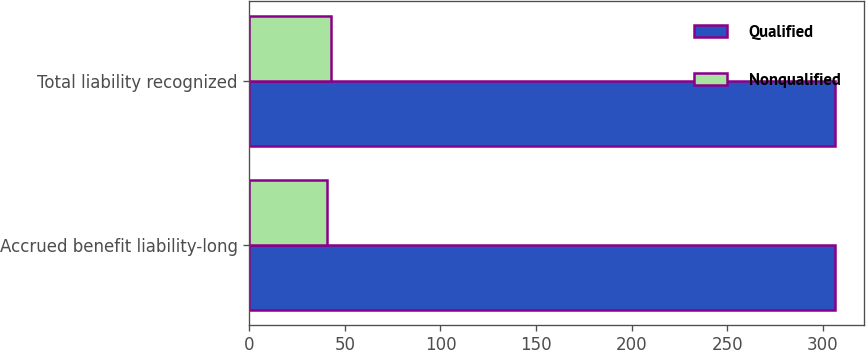Convert chart to OTSL. <chart><loc_0><loc_0><loc_500><loc_500><stacked_bar_chart><ecel><fcel>Accrued benefit liability-long<fcel>Total liability recognized<nl><fcel>Qualified<fcel>306.3<fcel>306.3<nl><fcel>Nonqualified<fcel>40.6<fcel>42.8<nl></chart> 